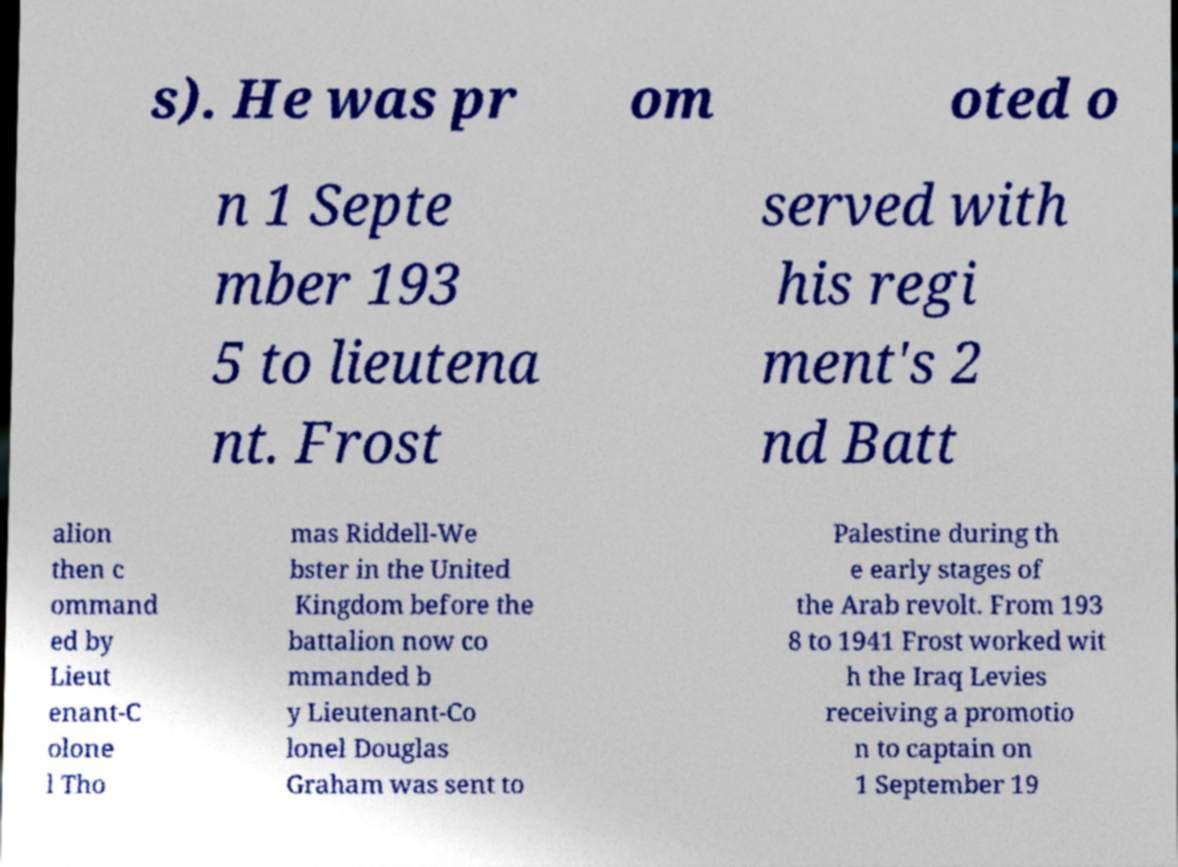Please identify and transcribe the text found in this image. s). He was pr om oted o n 1 Septe mber 193 5 to lieutena nt. Frost served with his regi ment's 2 nd Batt alion then c ommand ed by Lieut enant-C olone l Tho mas Riddell-We bster in the United Kingdom before the battalion now co mmanded b y Lieutenant-Co lonel Douglas Graham was sent to Palestine during th e early stages of the Arab revolt. From 193 8 to 1941 Frost worked wit h the Iraq Levies receiving a promotio n to captain on 1 September 19 